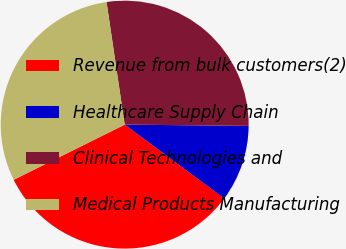Convert chart. <chart><loc_0><loc_0><loc_500><loc_500><pie_chart><fcel>Revenue from bulk customers(2)<fcel>Healthcare Supply Chain<fcel>Clinical Technologies and<fcel>Medical Products Manufacturing<nl><fcel>32.5%<fcel>10.0%<fcel>27.5%<fcel>30.0%<nl></chart> 